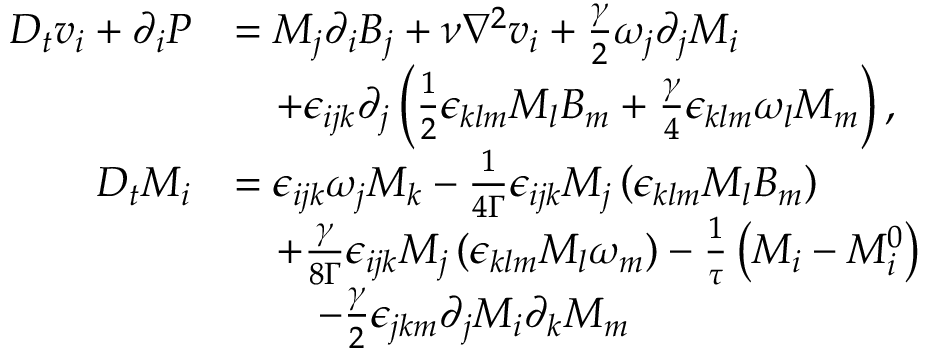Convert formula to latex. <formula><loc_0><loc_0><loc_500><loc_500>\begin{array} { r l } { D _ { t } v _ { i } + \partial _ { i } P } & { = M _ { j } \partial _ { i } B _ { j } + \nu \nabla ^ { 2 } v _ { i } + \frac { \gamma } { 2 } \omega _ { j } \partial _ { j } M _ { i } } \\ & { \quad + \epsilon _ { i j k } \partial _ { j } \left ( \frac { 1 } { 2 } \epsilon _ { k l m } M _ { l } B _ { m } + \frac { \gamma } { 4 } \epsilon _ { k l m } \omega _ { l } M _ { m } \right ) , } \\ { D _ { t } M _ { i } } & { = \epsilon _ { i j k } \omega _ { j } M _ { k } - \frac { 1 } { 4 \Gamma } \epsilon _ { i j k } M _ { j } \left ( \epsilon _ { k l m } M _ { l } B _ { m } \right ) } \\ & { \quad + \frac { \gamma } { 8 \Gamma } \epsilon _ { i j k } M _ { j } \left ( \epsilon _ { k l m } M _ { l } \omega _ { m } \right ) - \frac { 1 } { \tau } \left ( M _ { i } - M _ { i } ^ { 0 } \right ) } \\ & { \quad - \frac { \gamma } { 2 } \epsilon _ { j k m } \partial _ { j } M _ { i } \partial _ { k } M _ { m } } \end{array}</formula> 